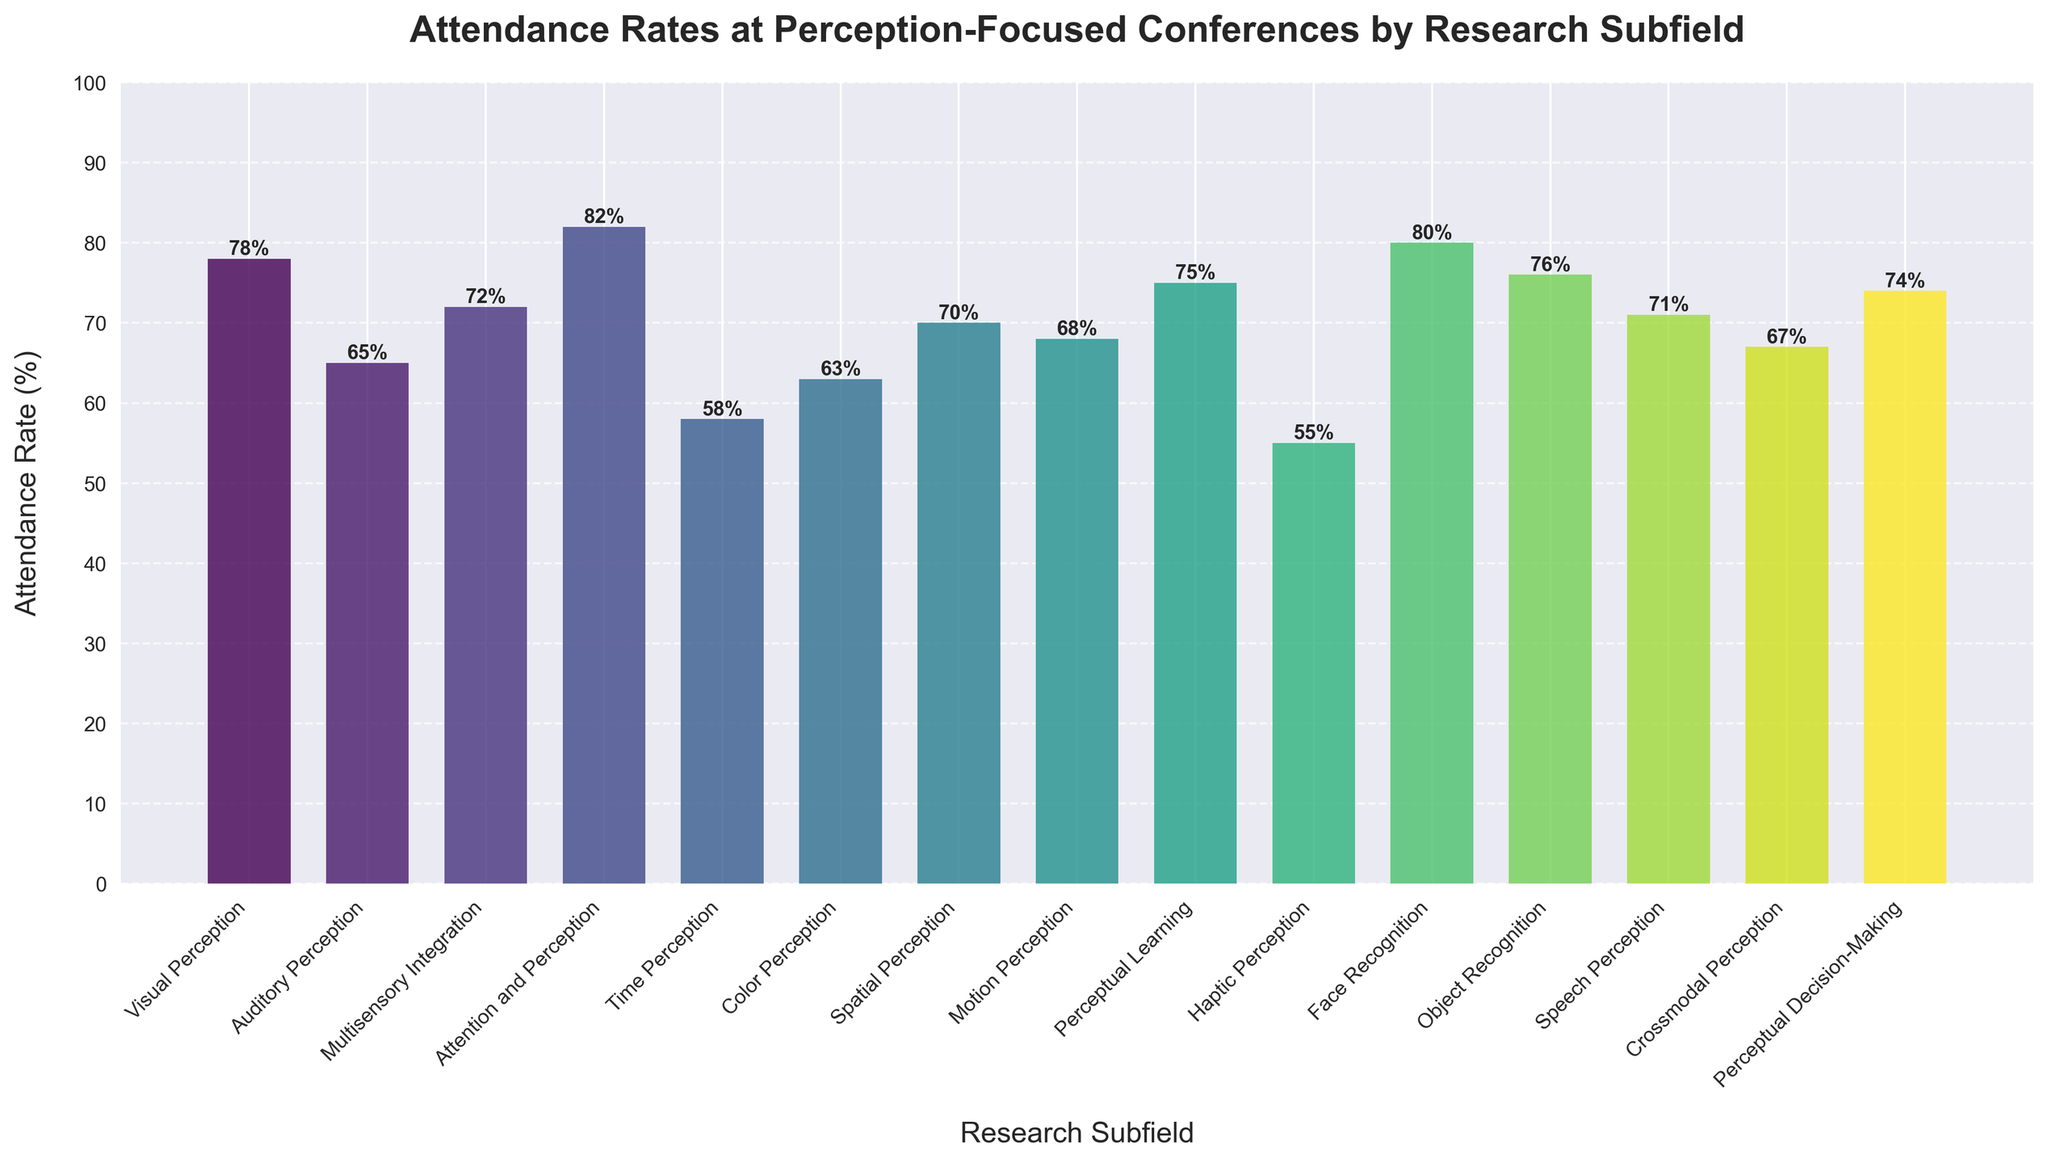Which subfield has the highest attendance rate? To find the subfield with the highest attendance rate, look for the tallest bar in the chart. The label for this bar identifies the subfield. The tallest bar corresponds to the "Attention and Perception" subfield.
Answer: Attention and Perception What is the difference in attendance rates between Visual Perception and Haptic Perception? Subtract the attendance rate of Haptic Perception (55) from Visual Perception (78). The calculation is 78 - 55 = 23.
Answer: 23 Which two subfields have the closest attendance rates? Look for bars that have heights that are very similar. "Auditory Perception" (65) and "Color Perception" (63) have rates that are close to each other. The difference is 2.
Answer: Auditory Perception and Color Perception How many subfields have an attendance rate of 70% or higher? Count the bars that reach or exceed the 70% mark. Those subfields are Visual Perception, Multisensory Integration, Attention and Perception, Face Recognition, Object Recognition, Perceptual Learning, and Speech Perception. There are 7 subfields.
Answer: 7 What is the average attendance rate for all the subfields? Sum the attendance rates for all subfields and divide by the number of subfields. The calculation is (78 + 65 + 72 + 82 + 58 + 63 + 70 + 68 + 75 + 55 + 80 + 76 + 71 + 67 + 74) / 15 = 68.
Answer: 68 Which subfield has a higher attendance rate: Face Recognition or Multisensory Integration? Compare the heights of the bars for Face Recognition (80) and Multisensory Integration (72). The Face Recognition bar is taller.
Answer: Face Recognition What is the median attendance rate among all subfields? First, order the attendance rates (55, 58, 63, 65, 67, 68, 70, 71, 72, 74, 75, 76, 78, 80, 82). The median is the middle value. Since there are 15 values, the median attendance rate is the 8th value: 71.
Answer: 71 Which subfield has the lowest attendance rate, and what is it? Identify the shortest bar in the chart. The label for this bar corresponds to the "Haptic Perception" subfield. The height is 55.
Answer: Haptic Perception, 55 